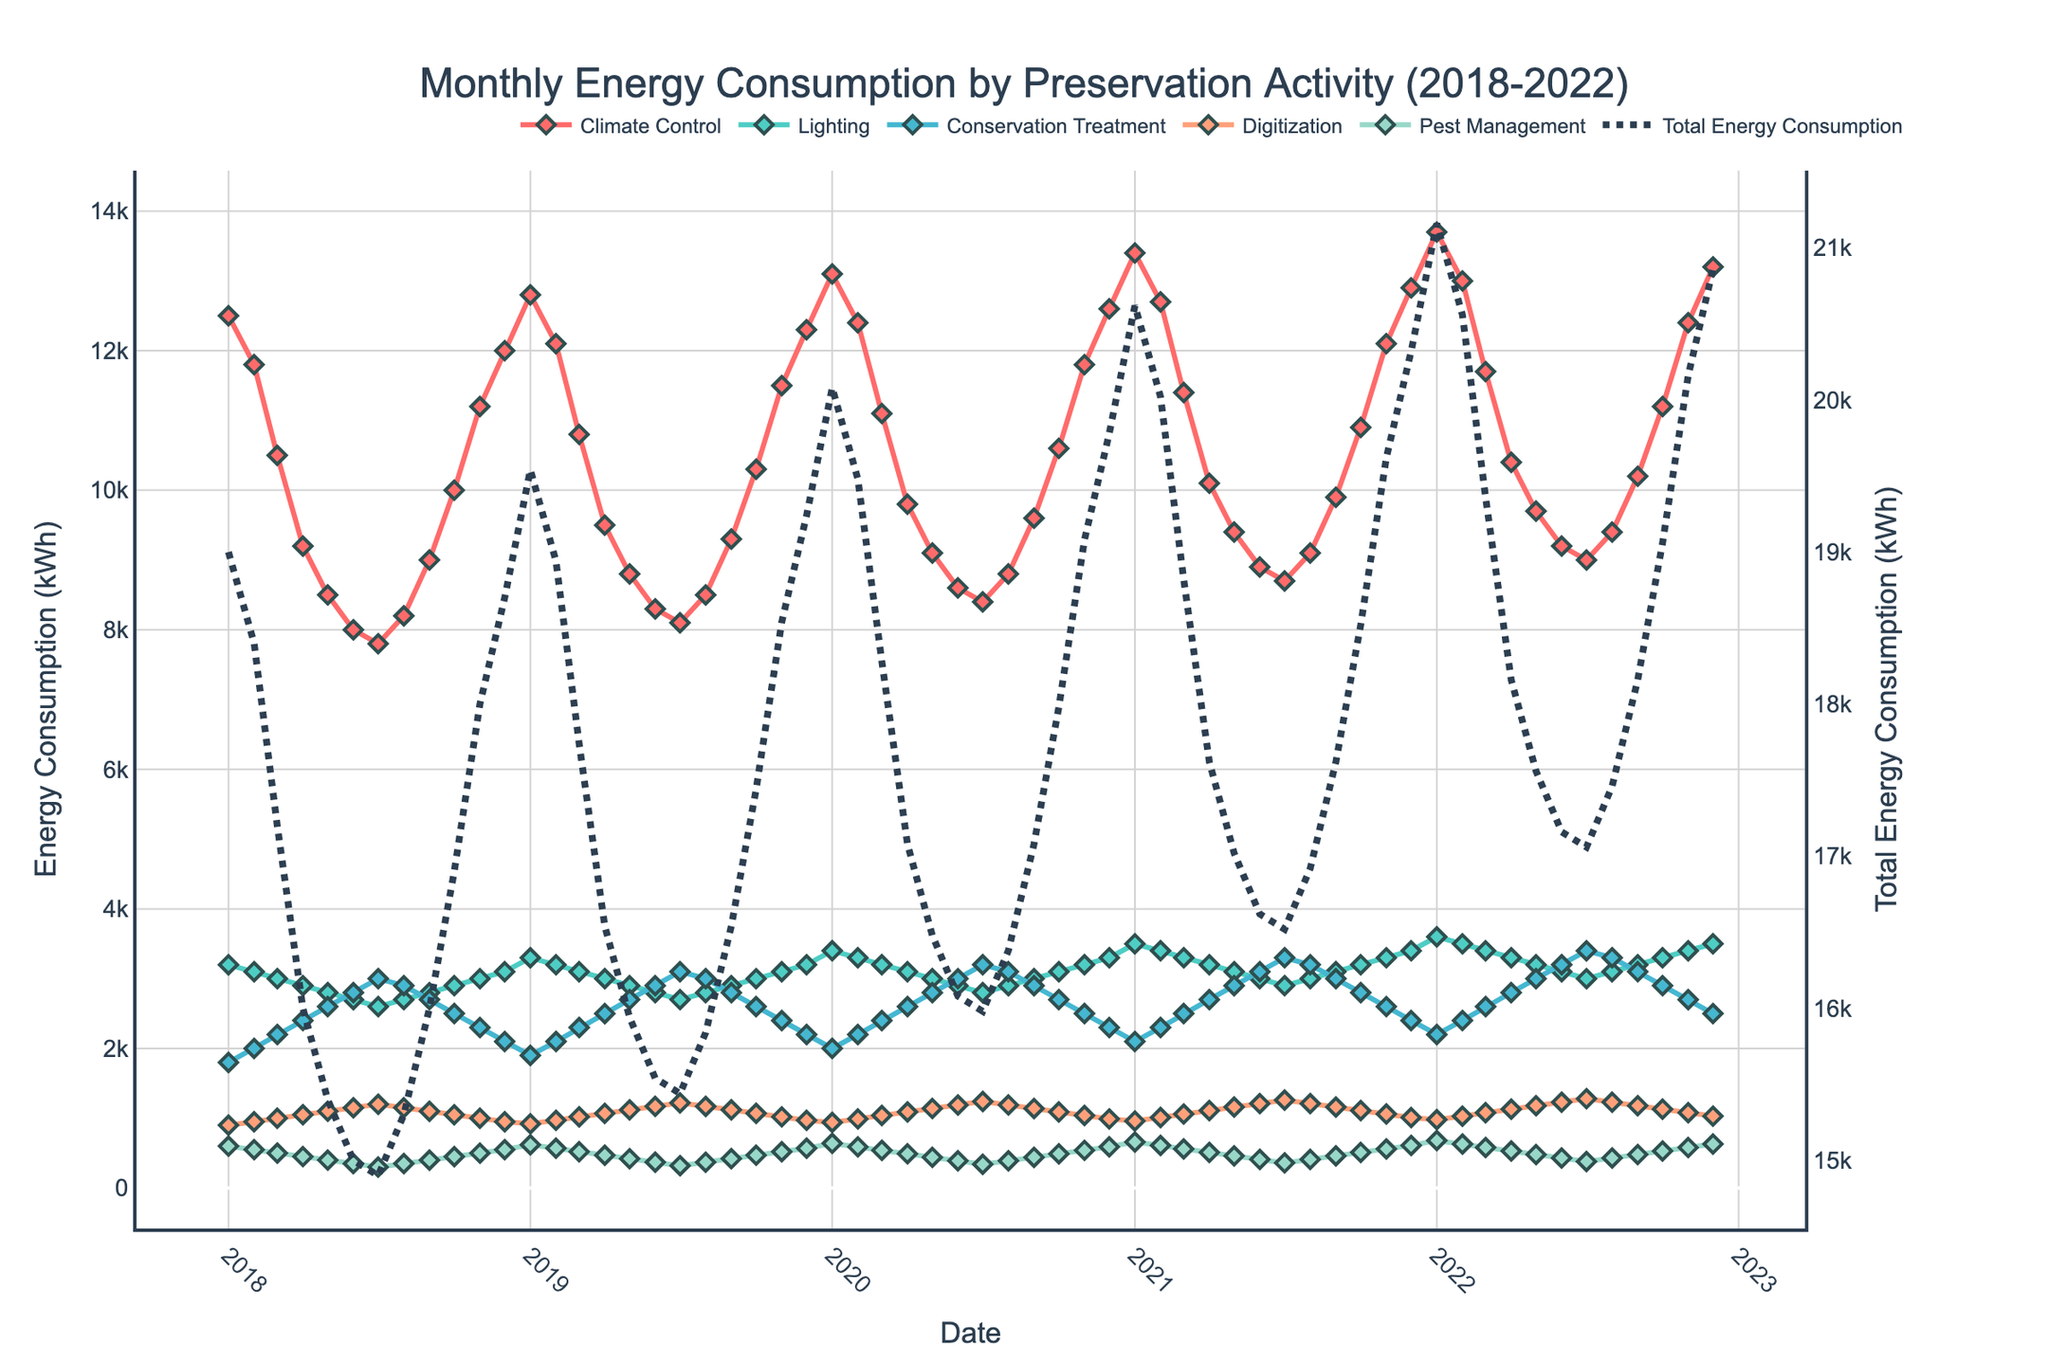What is the peak value for Climate Control energy consumption? By looking at the line corresponding to Climate Control, identify the highest point on the y-axis. This peak corresponds to the maximum value.
Answer: 13700 kWh Which preservation activity had the lowest energy consumption in August 2022? Refer to the data points for August 2022 and compare the values for all activities. Identify the smallest value.
Answer: Pest Management What is the average monthly energy consumption for Lighting in 2021? Sum all the values for Lighting in the year 2021 and divide by 12 (number of months). Calculation: (3500 + 3400 + 3300 + 3200 + 3100 + 3000 + 2900 + 3000 + 3100 + 3200 + 3300 + 3400) / 12.
Answer: 3225 kWh Which month and year had the highest total energy consumption? Observe the line corresponding to Total Energy Consumption and find the highest peak. Check the x-axis label for the corresponding date.
Answer: January 2022 Is the energy consumption for Digitization higher in July 2020 or July 2021? Compare the y-values for Digitization for both July 2020 and July 2021.
Answer: July 2021 How did the total energy consumption trend change between January 2018 and January 2022? Compare the total energy consumption value for January 2018 and January 2022. Describe the trend (increasing, decreasing, or stable).
Answer: Increasing What's the average annual energy consumption for Climate Control over the 5-year period? Sum all monthly values for Climate Control and divide by 60 (12 months/year * 5 years). Calculation: (12500+11800+10500+...+13200) / 60.
Answer: 10425 kWh Did Conservation Treatment's energy consumption show an increasing trend from 2018 to 2022? Observe the line corresponding to Conservation Treatment from 2018 to 2022. Identify if the line consistently trends upwards.
Answer: Yes Compare the total energy consumption in December 2021 and December 2022. Which month was higher? Look at the Total Energy Consumption line for December 2021 and December 2022. Compare the two values.
Answer: December 2022 